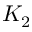<formula> <loc_0><loc_0><loc_500><loc_500>K _ { 2 }</formula> 